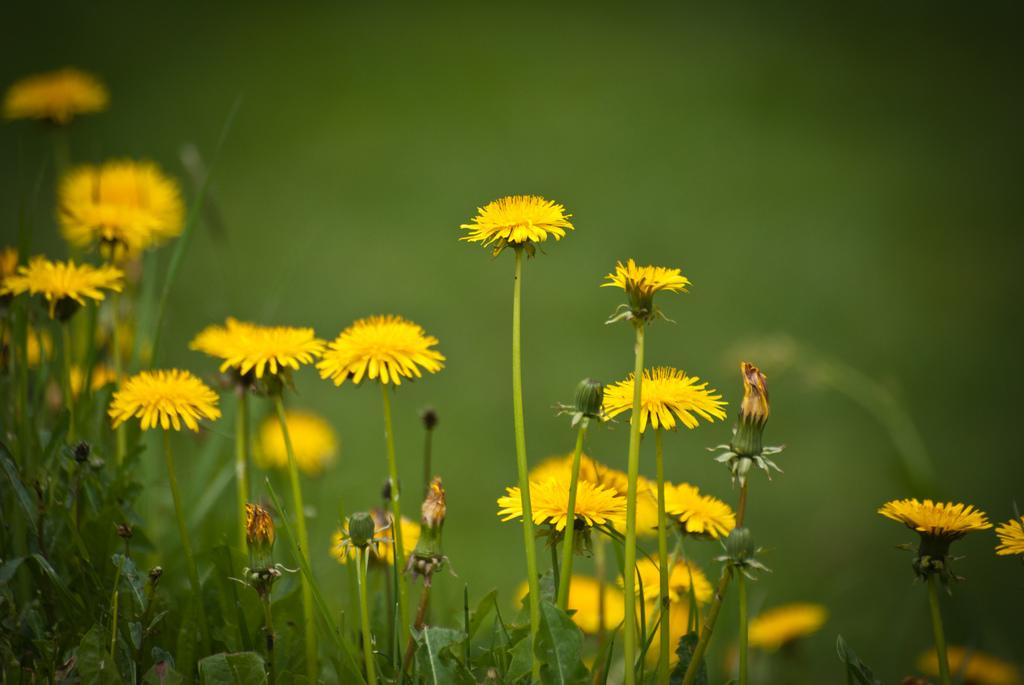What type of plants are in the image? The image contains flowered plants. What color are the flowers on the plants? The flowers are in yellow color. Can you describe the stage of the flowers on the plants? There are buds visible on the plants. What color is the background of the image? The background of the image is green in color. How is the background of the image depicted? The background is blurred. What type of operation is the man performing on the beggar in the image? There is no man or beggar present in the image; it features flowered plants with yellow flowers and green background. 